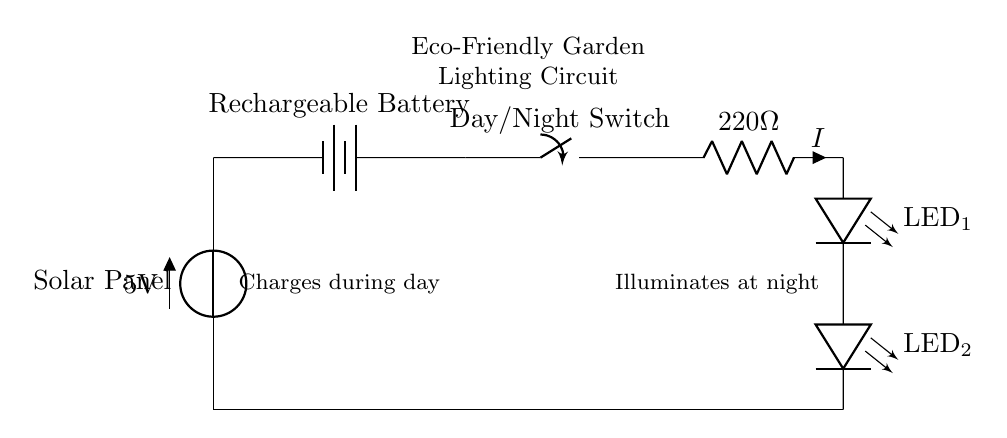What is the voltage supplied by the solar panel? The voltage supplied by the solar panel is 5 volts, as indicated on the circuit diagram.
Answer: 5 volts What component stores energy in the circuit? The component that stores energy is the rechargeable battery, which is designed to charge from the solar panel and supply power when needed.
Answer: Rechargeable battery How many LEDs are included in this circuit? There are two LEDs in this circuit, as shown in the series connection beneath the resistor.
Answer: Two What is the value of the resistor in the circuit? The value of the resistor is shown as 220 ohms, which limits the current flowing through the LEDs.
Answer: 220 ohms What is the purpose of the day/night switch? The day/night switch controls the flow of electricity, allowing the circuit to power the LEDs only at night when it is dark.
Answer: Control lighting Explain how the circuit charges during the day. During the day, the solar panel converts sunlight into electrical energy, which is then stored in the rechargeable battery. This is enabled by the connection from the solar panel to the battery, which is open during daylight hours for charging.
Answer: Solar charging Why are the LEDs connected in series? The LEDs are connected in series to ensure that the same current passes through each LED, which is important for their proper operation and luminance under the voltage supplied by the battery. If connected in parallel, the current would be divided and may not power them adequately.
Answer: Series connection 